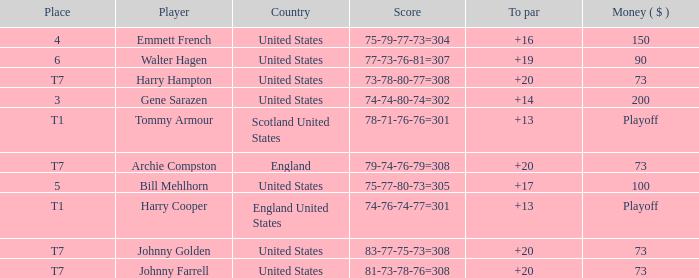What is the ranking for the United States when the money is $200? 3.0. 